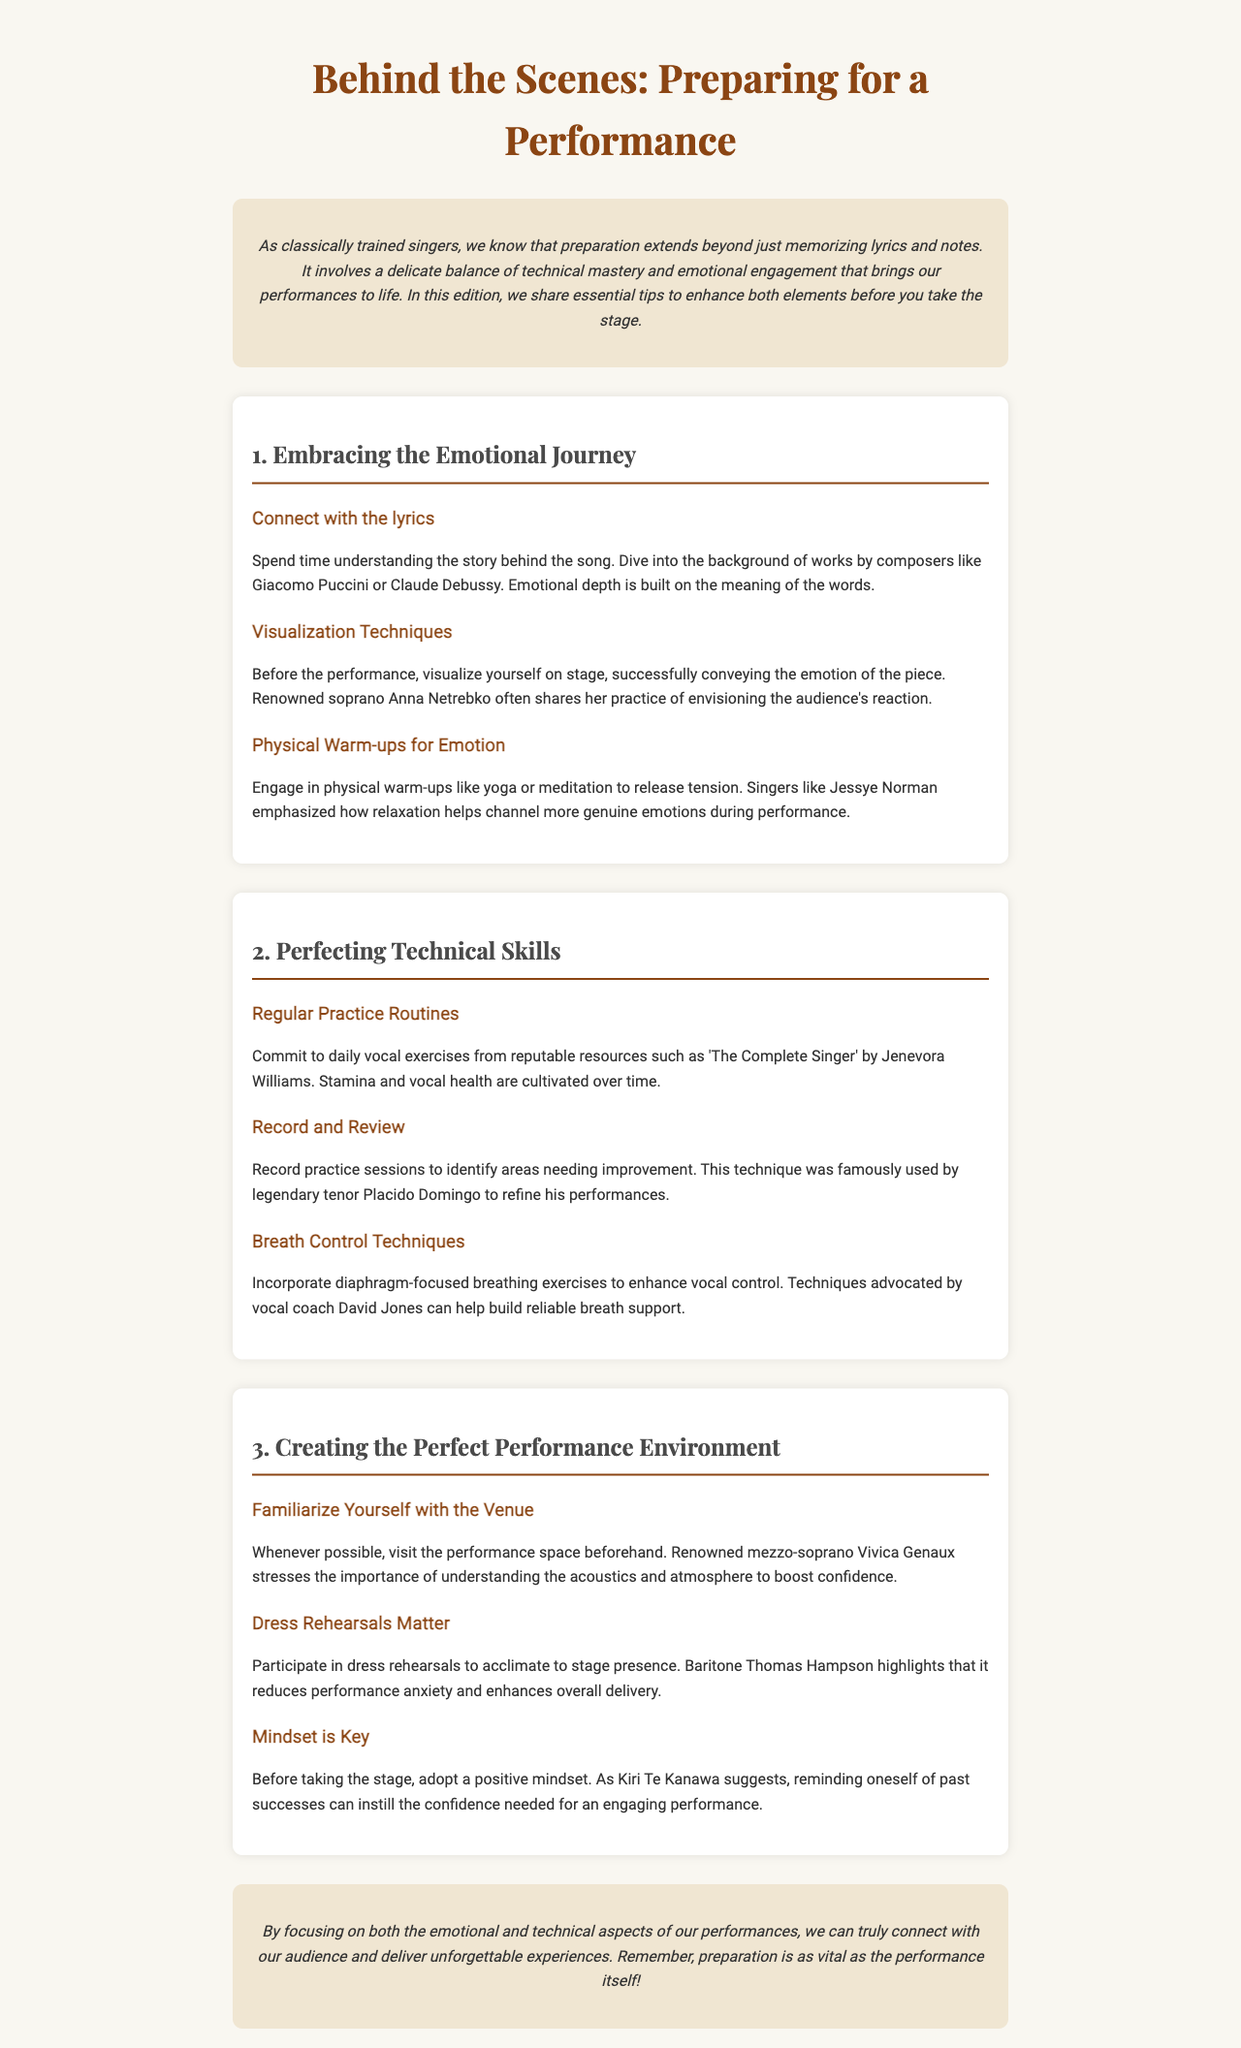What is the title of the newsletter? The title is clearly stated at the top of the document in the header section.
Answer: Behind the Scenes: Preparing for a Performance Who emphasized the importance of visualization techniques before a performance? This information is provided in the section about emotional engagement along with the mention of a specific soprano.
Answer: Anna Netrebko What does the newsletter suggest for enhancing emotional depth? This is described in the tips provided under the emotional journey section of the document.
Answer: Connect with the lyrics Which exercise is recommended for breath control? The document lists specific types of exercises in the section on perfecting technical skills.
Answer: Diaphragm-focused breathing exercises What is one benefit of participating in dress rehearsals? This is mentioned in the section about creating the perfect performance environment where a specific baritone is quoted.
Answer: Reduces performance anxiety What technique did Placido Domingo use to refine his performances? The document specifies a method used by the tenor in the technical skills section.
Answer: Record and Review Which famous mezzo-soprano stressed the importance of understanding acoustics? A specific name is provided in the section about creating the perfect performance environment.
Answer: Vivica Genaux How does Kiri Te Kanawa suggest boosting confidence before a performance? This is highlighted in the mindset tip under the section of creating a positive performance environment.
Answer: Reminding oneself of past successes 